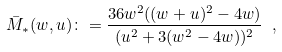<formula> <loc_0><loc_0><loc_500><loc_500>\bar { M } _ { * } ( w , u ) \colon = \frac { 3 6 w ^ { 2 } ( ( w + u ) ^ { 2 } - 4 w ) } { ( u ^ { 2 } + 3 ( w ^ { 2 } - 4 w ) ) ^ { 2 } } \ ,</formula> 